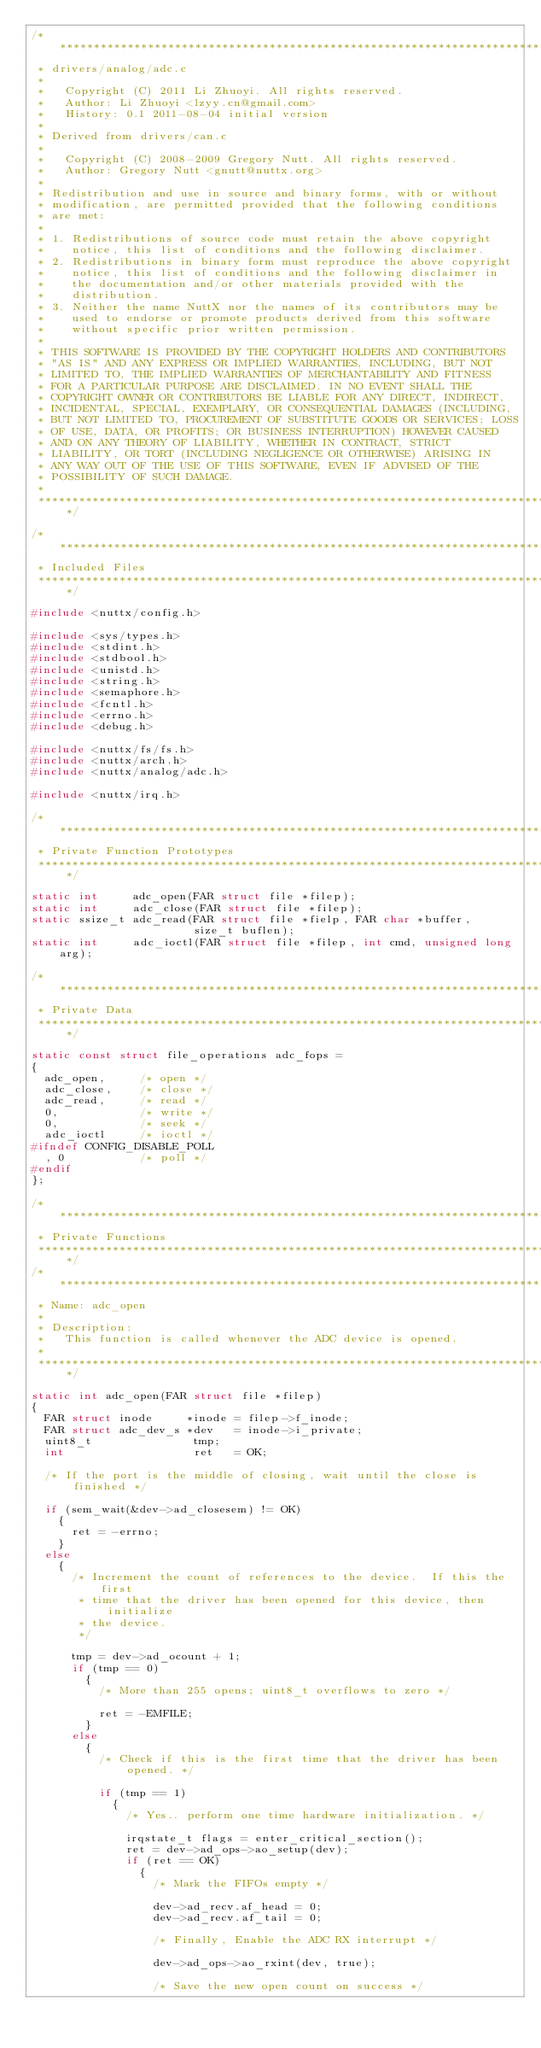Convert code to text. <code><loc_0><loc_0><loc_500><loc_500><_C_>/****************************************************************************
 * drivers/analog/adc.c
 *
 *   Copyright (C) 2011 Li Zhuoyi. All rights reserved.
 *   Author: Li Zhuoyi <lzyy.cn@gmail.com>
 *   History: 0.1 2011-08-04 initial version
 *
 * Derived from drivers/can.c
 *
 *   Copyright (C) 2008-2009 Gregory Nutt. All rights reserved.
 *   Author: Gregory Nutt <gnutt@nuttx.org>
 *
 * Redistribution and use in source and binary forms, with or without
 * modification, are permitted provided that the following conditions
 * are met:
 *
 * 1. Redistributions of source code must retain the above copyright
 *    notice, this list of conditions and the following disclaimer.
 * 2. Redistributions in binary form must reproduce the above copyright
 *    notice, this list of conditions and the following disclaimer in
 *    the documentation and/or other materials provided with the
 *    distribution.
 * 3. Neither the name NuttX nor the names of its contributors may be
 *    used to endorse or promote products derived from this software
 *    without specific prior written permission.
 *
 * THIS SOFTWARE IS PROVIDED BY THE COPYRIGHT HOLDERS AND CONTRIBUTORS
 * "AS IS" AND ANY EXPRESS OR IMPLIED WARRANTIES, INCLUDING, BUT NOT
 * LIMITED TO, THE IMPLIED WARRANTIES OF MERCHANTABILITY AND FITNESS
 * FOR A PARTICULAR PURPOSE ARE DISCLAIMED. IN NO EVENT SHALL THE
 * COPYRIGHT OWNER OR CONTRIBUTORS BE LIABLE FOR ANY DIRECT, INDIRECT,
 * INCIDENTAL, SPECIAL, EXEMPLARY, OR CONSEQUENTIAL DAMAGES (INCLUDING,
 * BUT NOT LIMITED TO, PROCUREMENT OF SUBSTITUTE GOODS OR SERVICES; LOSS
 * OF USE, DATA, OR PROFITS; OR BUSINESS INTERRUPTION) HOWEVER CAUSED
 * AND ON ANY THEORY OF LIABILITY, WHETHER IN CONTRACT, STRICT
 * LIABILITY, OR TORT (INCLUDING NEGLIGENCE OR OTHERWISE) ARISING IN
 * ANY WAY OUT OF THE USE OF THIS SOFTWARE, EVEN IF ADVISED OF THE
 * POSSIBILITY OF SUCH DAMAGE.
 *
 ****************************************************************************/

/****************************************************************************
 * Included Files
 ****************************************************************************/

#include <nuttx/config.h>

#include <sys/types.h>
#include <stdint.h>
#include <stdbool.h>
#include <unistd.h>
#include <string.h>
#include <semaphore.h>
#include <fcntl.h>
#include <errno.h>
#include <debug.h>

#include <nuttx/fs/fs.h>
#include <nuttx/arch.h>
#include <nuttx/analog/adc.h>

#include <nuttx/irq.h>

/****************************************************************************
 * Private Function Prototypes
 ****************************************************************************/

static int     adc_open(FAR struct file *filep);
static int     adc_close(FAR struct file *filep);
static ssize_t adc_read(FAR struct file *fielp, FAR char *buffer,
                        size_t buflen);
static int     adc_ioctl(FAR struct file *filep, int cmd, unsigned long arg);

/****************************************************************************
 * Private Data
 ****************************************************************************/

static const struct file_operations adc_fops =
{
  adc_open,     /* open */
  adc_close,    /* close */
  adc_read,     /* read */
  0,            /* write */
  0,            /* seek */
  adc_ioctl     /* ioctl */
#ifndef CONFIG_DISABLE_POLL
  , 0           /* poll */
#endif
};

/****************************************************************************
 * Private Functions
 ****************************************************************************/
/************************************************************************************
 * Name: adc_open
 *
 * Description:
 *   This function is called whenever the ADC device is opened.
 *
 ************************************************************************************/

static int adc_open(FAR struct file *filep)
{
  FAR struct inode     *inode = filep->f_inode;
  FAR struct adc_dev_s *dev   = inode->i_private;
  uint8_t               tmp;
  int                   ret   = OK;

  /* If the port is the middle of closing, wait until the close is finished */

  if (sem_wait(&dev->ad_closesem) != OK)
    {
      ret = -errno;
    }
  else
    {
      /* Increment the count of references to the device.  If this the first
       * time that the driver has been opened for this device, then initialize
       * the device.
       */

      tmp = dev->ad_ocount + 1;
      if (tmp == 0)
        {
          /* More than 255 opens; uint8_t overflows to zero */

          ret = -EMFILE;
        }
      else
        {
          /* Check if this is the first time that the driver has been opened. */

          if (tmp == 1)
            {
              /* Yes.. perform one time hardware initialization. */

              irqstate_t flags = enter_critical_section();
              ret = dev->ad_ops->ao_setup(dev);
              if (ret == OK)
                {
                  /* Mark the FIFOs empty */

                  dev->ad_recv.af_head = 0;
                  dev->ad_recv.af_tail = 0;

                  /* Finally, Enable the ADC RX interrupt */

                  dev->ad_ops->ao_rxint(dev, true);

                  /* Save the new open count on success */
</code> 